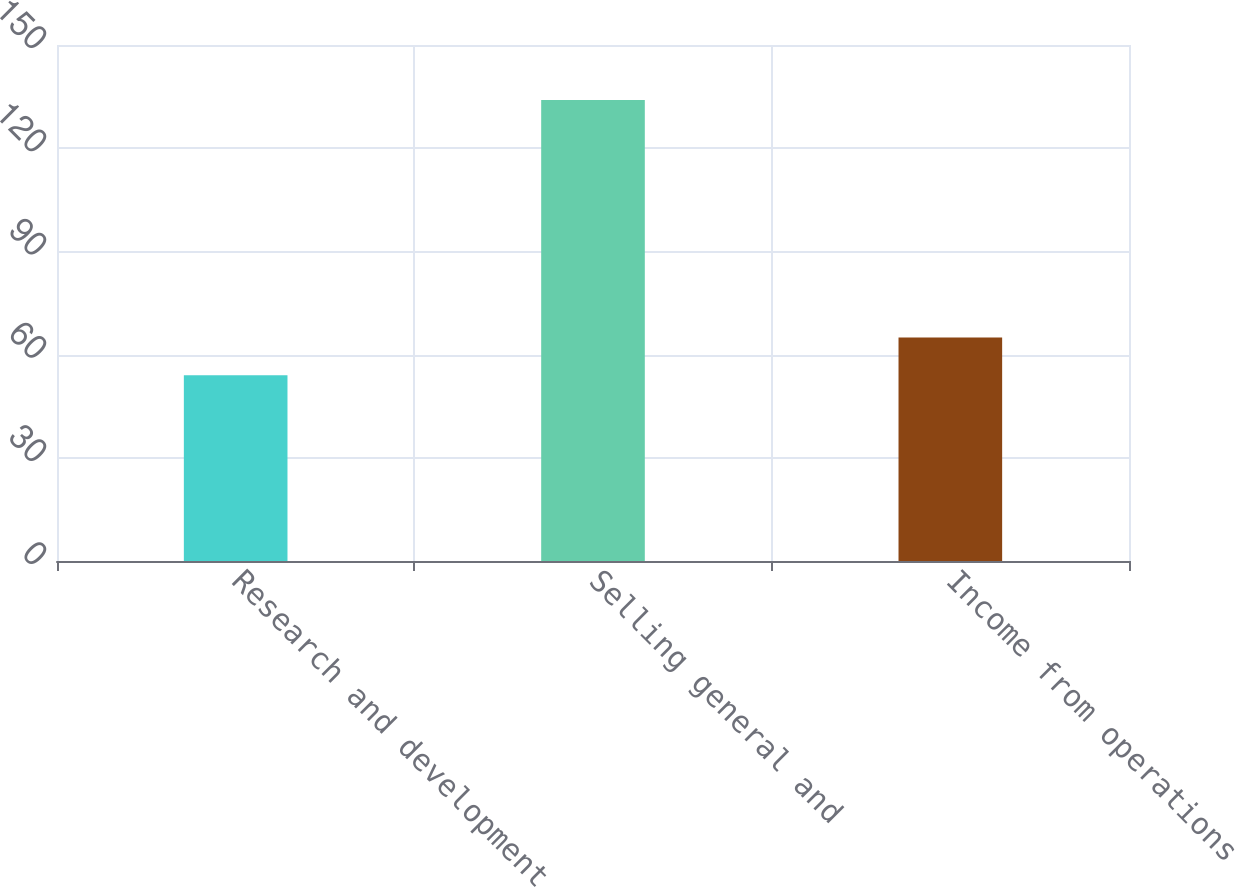Convert chart to OTSL. <chart><loc_0><loc_0><loc_500><loc_500><bar_chart><fcel>Research and development<fcel>Selling general and<fcel>Income from operations<nl><fcel>54<fcel>134<fcel>65<nl></chart> 